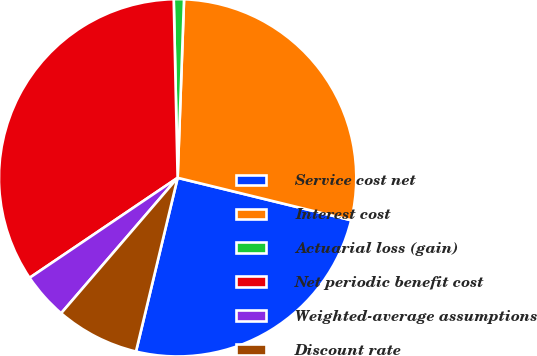<chart> <loc_0><loc_0><loc_500><loc_500><pie_chart><fcel>Service cost net<fcel>Interest cost<fcel>Actuarial loss (gain)<fcel>Net periodic benefit cost<fcel>Weighted-average assumptions<fcel>Discount rate<nl><fcel>24.93%<fcel>28.25%<fcel>0.92%<fcel>34.11%<fcel>4.24%<fcel>7.56%<nl></chart> 